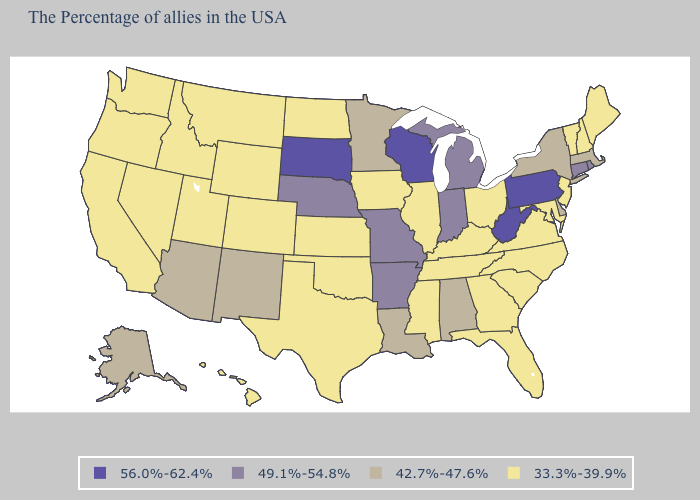Among the states that border Georgia , does Alabama have the highest value?
Be succinct. Yes. Does North Carolina have the lowest value in the USA?
Keep it brief. Yes. How many symbols are there in the legend?
Short answer required. 4. What is the lowest value in states that border New York?
Give a very brief answer. 33.3%-39.9%. Which states have the lowest value in the MidWest?
Keep it brief. Ohio, Illinois, Iowa, Kansas, North Dakota. Does the first symbol in the legend represent the smallest category?
Write a very short answer. No. Does the first symbol in the legend represent the smallest category?
Keep it brief. No. Name the states that have a value in the range 42.7%-47.6%?
Give a very brief answer. Massachusetts, New York, Delaware, Alabama, Louisiana, Minnesota, New Mexico, Arizona, Alaska. What is the highest value in the USA?
Short answer required. 56.0%-62.4%. What is the highest value in the MidWest ?
Keep it brief. 56.0%-62.4%. Among the states that border Illinois , does Kentucky have the lowest value?
Quick response, please. Yes. What is the value of Iowa?
Give a very brief answer. 33.3%-39.9%. What is the lowest value in the MidWest?
Be succinct. 33.3%-39.9%. Does Pennsylvania have the highest value in the Northeast?
Short answer required. Yes. What is the value of Illinois?
Write a very short answer. 33.3%-39.9%. 